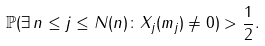<formula> <loc_0><loc_0><loc_500><loc_500>\mathbb { P } ( \exists \, { n \leq j \leq N ( n ) } \colon X _ { j } ( m _ { j } ) \neq 0 ) > \frac { 1 } { 2 } .</formula> 